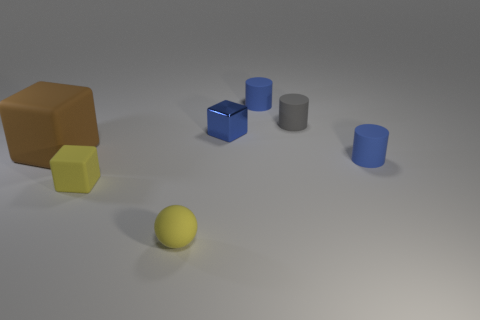What number of other things are the same color as the shiny cube?
Keep it short and to the point. 2. The brown block has what size?
Your answer should be very brief. Large. Are there more brown objects that are to the left of the tiny gray matte thing than small rubber spheres that are left of the blue shiny thing?
Your answer should be compact. No. How many tiny gray cylinders are to the right of the blue cylinder in front of the tiny blue metal thing?
Provide a short and direct response. 0. There is a tiny blue object that is behind the small shiny cube; is it the same shape as the blue metallic thing?
Provide a short and direct response. No. What is the material of the small yellow thing that is the same shape as the small blue metal thing?
Offer a terse response. Rubber. How many other rubber balls have the same size as the matte ball?
Your answer should be very brief. 0. What is the color of the tiny thing that is behind the large brown matte thing and in front of the gray matte thing?
Your answer should be compact. Blue. Is the number of yellow matte objects less than the number of small blue metal cubes?
Ensure brevity in your answer.  No. Does the rubber sphere have the same color as the cylinder behind the tiny gray thing?
Provide a succinct answer. No. 